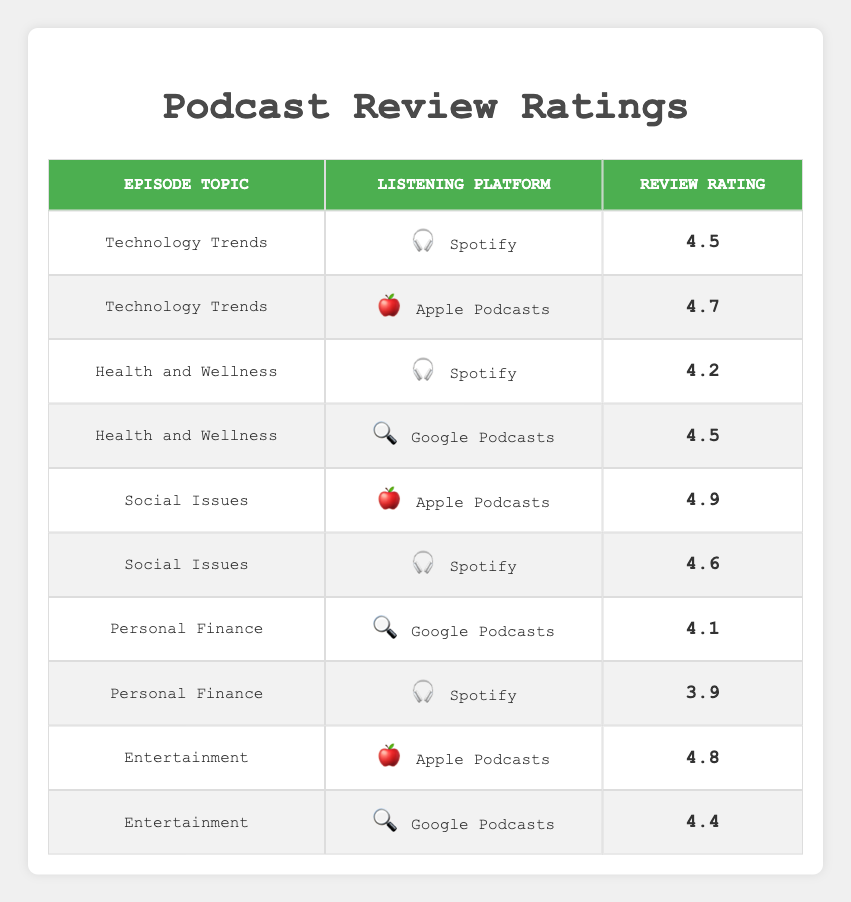What is the highest review rating for the episode topic "Social Issues"? The highest review rating for "Social Issues" is found by looking at the two entries for this topic in the table. We see that "Social Issues" has a rating of 4.9 for Apple Podcasts and a rating of 4.6 for Spotify. Comparing these, 4.9 is the highest.
Answer: 4.9 Which episode topic received the lowest rating on Spotify? Looking at the Spotify entries in the table, the ratings for each episode topic are: Technology Trends (4.5), Health and Wellness (4.2), Social Issues (4.6), Personal Finance (3.9). The lowest rating among these is 3.9 for Personal Finance.
Answer: 3.9 Is there any episode topic that received a rating of 4.7 or higher on Google Podcasts? Checking the Google Podcasts entries in the table, we have "Health and Wellness" at 4.5, "Personal Finance" at 4.1, and "Entertainment" at 4.4. None of these ratings reach 4.7, which means the answer is no.
Answer: No What is the average review rating for episodes on Apple Podcasts? To compute the average rating for Apple Podcasts, we take the ratings: 4.7 (Technology Trends), 4.9 (Social Issues), 4.8 (Entertainment). The sum of these ratings is 4.7 + 4.9 + 4.8 = 14.4. Dividing this by the total number of ratings (3) gives an average of 14.4 / 3 = 4.8.
Answer: 4.8 Which listening platform has the highest average rating across all episode topics? First, we calculate the average ratings per platform. For Spotify: (4.5 + 4.2 + 4.6 + 3.9) = 17.2, divided by 4 = 4.3. For Apple Podcasts: (4.7 + 4.9 + 4.8) = 14.4, divided by 3 = 4.8. For Google Podcasts: (4.5 + 4.1 + 4.4) = 13.0, divided by 3 = 4.33. Comparing the averages, Apple Podcasts has the highest average at 4.8.
Answer: Apple Podcasts 